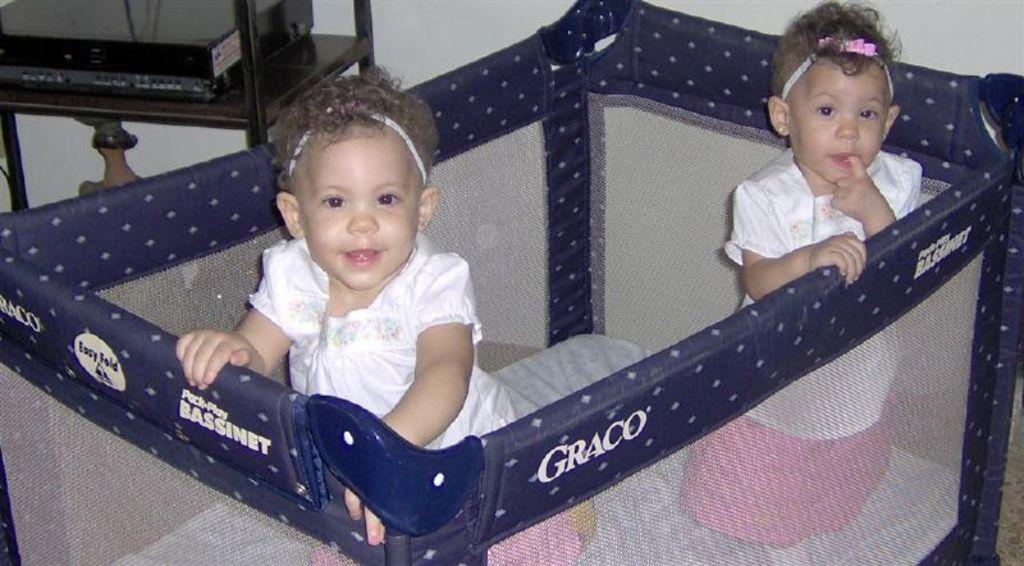How many girls are present in the image? There are two small girls in the image. What are the girls doing in the image? The girls are inside a cradle. What electronic device can be seen in the image? There is a television on a desk in the image. Where is the television located in the image? The television is at the top side of the image. What type of knife is being used by the girls in the image? There is no knife present in the image; the girls are inside a cradle. What is the current weather like in the image? The provided facts do not mention any information about the weather, so it cannot be determined from the image. 